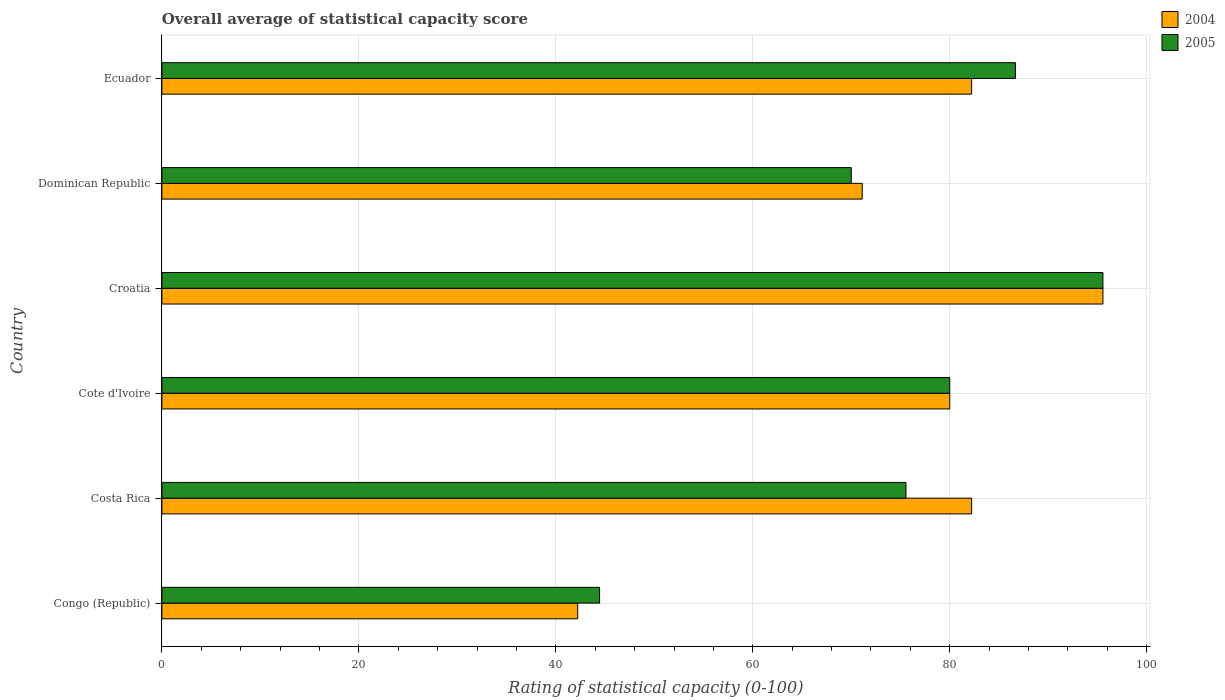How many different coloured bars are there?
Make the answer very short. 2. How many groups of bars are there?
Provide a short and direct response. 6. Are the number of bars on each tick of the Y-axis equal?
Offer a terse response. Yes. What is the label of the 3rd group of bars from the top?
Ensure brevity in your answer.  Croatia. In how many cases, is the number of bars for a given country not equal to the number of legend labels?
Give a very brief answer. 0. What is the rating of statistical capacity in 2004 in Ecuador?
Provide a succinct answer. 82.22. Across all countries, what is the maximum rating of statistical capacity in 2005?
Give a very brief answer. 95.56. Across all countries, what is the minimum rating of statistical capacity in 2005?
Offer a terse response. 44.44. In which country was the rating of statistical capacity in 2004 maximum?
Ensure brevity in your answer.  Croatia. In which country was the rating of statistical capacity in 2004 minimum?
Offer a terse response. Congo (Republic). What is the total rating of statistical capacity in 2004 in the graph?
Keep it short and to the point. 453.33. What is the difference between the rating of statistical capacity in 2004 in Congo (Republic) and that in Costa Rica?
Your answer should be very brief. -40. What is the difference between the rating of statistical capacity in 2005 in Costa Rica and the rating of statistical capacity in 2004 in Dominican Republic?
Provide a succinct answer. 4.44. What is the average rating of statistical capacity in 2004 per country?
Your response must be concise. 75.56. What is the difference between the rating of statistical capacity in 2004 and rating of statistical capacity in 2005 in Ecuador?
Your response must be concise. -4.44. What is the ratio of the rating of statistical capacity in 2004 in Croatia to that in Ecuador?
Make the answer very short. 1.16. Is the rating of statistical capacity in 2004 in Costa Rica less than that in Croatia?
Make the answer very short. Yes. What is the difference between the highest and the second highest rating of statistical capacity in 2004?
Your answer should be very brief. 13.33. What is the difference between the highest and the lowest rating of statistical capacity in 2005?
Your response must be concise. 51.11. How many bars are there?
Your answer should be compact. 12. Does the graph contain grids?
Offer a very short reply. Yes. What is the title of the graph?
Ensure brevity in your answer.  Overall average of statistical capacity score. Does "2002" appear as one of the legend labels in the graph?
Provide a short and direct response. No. What is the label or title of the X-axis?
Your answer should be very brief. Rating of statistical capacity (0-100). What is the label or title of the Y-axis?
Your answer should be very brief. Country. What is the Rating of statistical capacity (0-100) of 2004 in Congo (Republic)?
Offer a very short reply. 42.22. What is the Rating of statistical capacity (0-100) in 2005 in Congo (Republic)?
Offer a very short reply. 44.44. What is the Rating of statistical capacity (0-100) in 2004 in Costa Rica?
Keep it short and to the point. 82.22. What is the Rating of statistical capacity (0-100) in 2005 in Costa Rica?
Make the answer very short. 75.56. What is the Rating of statistical capacity (0-100) of 2004 in Cote d'Ivoire?
Your response must be concise. 80. What is the Rating of statistical capacity (0-100) in 2004 in Croatia?
Provide a short and direct response. 95.56. What is the Rating of statistical capacity (0-100) in 2005 in Croatia?
Provide a succinct answer. 95.56. What is the Rating of statistical capacity (0-100) of 2004 in Dominican Republic?
Your answer should be compact. 71.11. What is the Rating of statistical capacity (0-100) in 2004 in Ecuador?
Ensure brevity in your answer.  82.22. What is the Rating of statistical capacity (0-100) in 2005 in Ecuador?
Give a very brief answer. 86.67. Across all countries, what is the maximum Rating of statistical capacity (0-100) in 2004?
Your response must be concise. 95.56. Across all countries, what is the maximum Rating of statistical capacity (0-100) in 2005?
Provide a succinct answer. 95.56. Across all countries, what is the minimum Rating of statistical capacity (0-100) in 2004?
Provide a succinct answer. 42.22. Across all countries, what is the minimum Rating of statistical capacity (0-100) in 2005?
Offer a very short reply. 44.44. What is the total Rating of statistical capacity (0-100) in 2004 in the graph?
Offer a very short reply. 453.33. What is the total Rating of statistical capacity (0-100) of 2005 in the graph?
Your answer should be compact. 452.22. What is the difference between the Rating of statistical capacity (0-100) in 2005 in Congo (Republic) and that in Costa Rica?
Your answer should be compact. -31.11. What is the difference between the Rating of statistical capacity (0-100) in 2004 in Congo (Republic) and that in Cote d'Ivoire?
Offer a very short reply. -37.78. What is the difference between the Rating of statistical capacity (0-100) of 2005 in Congo (Republic) and that in Cote d'Ivoire?
Ensure brevity in your answer.  -35.56. What is the difference between the Rating of statistical capacity (0-100) in 2004 in Congo (Republic) and that in Croatia?
Keep it short and to the point. -53.33. What is the difference between the Rating of statistical capacity (0-100) in 2005 in Congo (Republic) and that in Croatia?
Your answer should be compact. -51.11. What is the difference between the Rating of statistical capacity (0-100) in 2004 in Congo (Republic) and that in Dominican Republic?
Provide a short and direct response. -28.89. What is the difference between the Rating of statistical capacity (0-100) of 2005 in Congo (Republic) and that in Dominican Republic?
Make the answer very short. -25.56. What is the difference between the Rating of statistical capacity (0-100) in 2005 in Congo (Republic) and that in Ecuador?
Provide a succinct answer. -42.22. What is the difference between the Rating of statistical capacity (0-100) of 2004 in Costa Rica and that in Cote d'Ivoire?
Offer a terse response. 2.22. What is the difference between the Rating of statistical capacity (0-100) in 2005 in Costa Rica and that in Cote d'Ivoire?
Your answer should be very brief. -4.44. What is the difference between the Rating of statistical capacity (0-100) in 2004 in Costa Rica and that in Croatia?
Keep it short and to the point. -13.33. What is the difference between the Rating of statistical capacity (0-100) of 2004 in Costa Rica and that in Dominican Republic?
Your answer should be compact. 11.11. What is the difference between the Rating of statistical capacity (0-100) in 2005 in Costa Rica and that in Dominican Republic?
Make the answer very short. 5.56. What is the difference between the Rating of statistical capacity (0-100) of 2004 in Costa Rica and that in Ecuador?
Your response must be concise. 0. What is the difference between the Rating of statistical capacity (0-100) in 2005 in Costa Rica and that in Ecuador?
Keep it short and to the point. -11.11. What is the difference between the Rating of statistical capacity (0-100) of 2004 in Cote d'Ivoire and that in Croatia?
Keep it short and to the point. -15.56. What is the difference between the Rating of statistical capacity (0-100) of 2005 in Cote d'Ivoire and that in Croatia?
Offer a very short reply. -15.56. What is the difference between the Rating of statistical capacity (0-100) of 2004 in Cote d'Ivoire and that in Dominican Republic?
Give a very brief answer. 8.89. What is the difference between the Rating of statistical capacity (0-100) in 2005 in Cote d'Ivoire and that in Dominican Republic?
Offer a very short reply. 10. What is the difference between the Rating of statistical capacity (0-100) in 2004 in Cote d'Ivoire and that in Ecuador?
Offer a very short reply. -2.22. What is the difference between the Rating of statistical capacity (0-100) of 2005 in Cote d'Ivoire and that in Ecuador?
Ensure brevity in your answer.  -6.67. What is the difference between the Rating of statistical capacity (0-100) of 2004 in Croatia and that in Dominican Republic?
Keep it short and to the point. 24.44. What is the difference between the Rating of statistical capacity (0-100) of 2005 in Croatia and that in Dominican Republic?
Offer a terse response. 25.56. What is the difference between the Rating of statistical capacity (0-100) in 2004 in Croatia and that in Ecuador?
Give a very brief answer. 13.33. What is the difference between the Rating of statistical capacity (0-100) of 2005 in Croatia and that in Ecuador?
Offer a very short reply. 8.89. What is the difference between the Rating of statistical capacity (0-100) in 2004 in Dominican Republic and that in Ecuador?
Your answer should be very brief. -11.11. What is the difference between the Rating of statistical capacity (0-100) of 2005 in Dominican Republic and that in Ecuador?
Keep it short and to the point. -16.67. What is the difference between the Rating of statistical capacity (0-100) of 2004 in Congo (Republic) and the Rating of statistical capacity (0-100) of 2005 in Costa Rica?
Offer a terse response. -33.33. What is the difference between the Rating of statistical capacity (0-100) in 2004 in Congo (Republic) and the Rating of statistical capacity (0-100) in 2005 in Cote d'Ivoire?
Offer a terse response. -37.78. What is the difference between the Rating of statistical capacity (0-100) in 2004 in Congo (Republic) and the Rating of statistical capacity (0-100) in 2005 in Croatia?
Give a very brief answer. -53.33. What is the difference between the Rating of statistical capacity (0-100) in 2004 in Congo (Republic) and the Rating of statistical capacity (0-100) in 2005 in Dominican Republic?
Your answer should be compact. -27.78. What is the difference between the Rating of statistical capacity (0-100) in 2004 in Congo (Republic) and the Rating of statistical capacity (0-100) in 2005 in Ecuador?
Ensure brevity in your answer.  -44.44. What is the difference between the Rating of statistical capacity (0-100) in 2004 in Costa Rica and the Rating of statistical capacity (0-100) in 2005 in Cote d'Ivoire?
Your answer should be very brief. 2.22. What is the difference between the Rating of statistical capacity (0-100) in 2004 in Costa Rica and the Rating of statistical capacity (0-100) in 2005 in Croatia?
Give a very brief answer. -13.33. What is the difference between the Rating of statistical capacity (0-100) of 2004 in Costa Rica and the Rating of statistical capacity (0-100) of 2005 in Dominican Republic?
Give a very brief answer. 12.22. What is the difference between the Rating of statistical capacity (0-100) in 2004 in Costa Rica and the Rating of statistical capacity (0-100) in 2005 in Ecuador?
Offer a terse response. -4.44. What is the difference between the Rating of statistical capacity (0-100) of 2004 in Cote d'Ivoire and the Rating of statistical capacity (0-100) of 2005 in Croatia?
Your response must be concise. -15.56. What is the difference between the Rating of statistical capacity (0-100) of 2004 in Cote d'Ivoire and the Rating of statistical capacity (0-100) of 2005 in Ecuador?
Provide a succinct answer. -6.67. What is the difference between the Rating of statistical capacity (0-100) of 2004 in Croatia and the Rating of statistical capacity (0-100) of 2005 in Dominican Republic?
Offer a terse response. 25.56. What is the difference between the Rating of statistical capacity (0-100) of 2004 in Croatia and the Rating of statistical capacity (0-100) of 2005 in Ecuador?
Ensure brevity in your answer.  8.89. What is the difference between the Rating of statistical capacity (0-100) of 2004 in Dominican Republic and the Rating of statistical capacity (0-100) of 2005 in Ecuador?
Offer a very short reply. -15.56. What is the average Rating of statistical capacity (0-100) in 2004 per country?
Give a very brief answer. 75.56. What is the average Rating of statistical capacity (0-100) in 2005 per country?
Your response must be concise. 75.37. What is the difference between the Rating of statistical capacity (0-100) in 2004 and Rating of statistical capacity (0-100) in 2005 in Congo (Republic)?
Offer a terse response. -2.22. What is the difference between the Rating of statistical capacity (0-100) of 2004 and Rating of statistical capacity (0-100) of 2005 in Cote d'Ivoire?
Your response must be concise. 0. What is the difference between the Rating of statistical capacity (0-100) in 2004 and Rating of statistical capacity (0-100) in 2005 in Dominican Republic?
Provide a succinct answer. 1.11. What is the difference between the Rating of statistical capacity (0-100) in 2004 and Rating of statistical capacity (0-100) in 2005 in Ecuador?
Your response must be concise. -4.44. What is the ratio of the Rating of statistical capacity (0-100) of 2004 in Congo (Republic) to that in Costa Rica?
Your answer should be very brief. 0.51. What is the ratio of the Rating of statistical capacity (0-100) in 2005 in Congo (Republic) to that in Costa Rica?
Make the answer very short. 0.59. What is the ratio of the Rating of statistical capacity (0-100) in 2004 in Congo (Republic) to that in Cote d'Ivoire?
Your answer should be compact. 0.53. What is the ratio of the Rating of statistical capacity (0-100) of 2005 in Congo (Republic) to that in Cote d'Ivoire?
Give a very brief answer. 0.56. What is the ratio of the Rating of statistical capacity (0-100) in 2004 in Congo (Republic) to that in Croatia?
Keep it short and to the point. 0.44. What is the ratio of the Rating of statistical capacity (0-100) of 2005 in Congo (Republic) to that in Croatia?
Your answer should be very brief. 0.47. What is the ratio of the Rating of statistical capacity (0-100) of 2004 in Congo (Republic) to that in Dominican Republic?
Offer a terse response. 0.59. What is the ratio of the Rating of statistical capacity (0-100) of 2005 in Congo (Republic) to that in Dominican Republic?
Provide a short and direct response. 0.63. What is the ratio of the Rating of statistical capacity (0-100) of 2004 in Congo (Republic) to that in Ecuador?
Your answer should be very brief. 0.51. What is the ratio of the Rating of statistical capacity (0-100) of 2005 in Congo (Republic) to that in Ecuador?
Your answer should be compact. 0.51. What is the ratio of the Rating of statistical capacity (0-100) of 2004 in Costa Rica to that in Cote d'Ivoire?
Give a very brief answer. 1.03. What is the ratio of the Rating of statistical capacity (0-100) in 2005 in Costa Rica to that in Cote d'Ivoire?
Your answer should be very brief. 0.94. What is the ratio of the Rating of statistical capacity (0-100) in 2004 in Costa Rica to that in Croatia?
Your response must be concise. 0.86. What is the ratio of the Rating of statistical capacity (0-100) of 2005 in Costa Rica to that in Croatia?
Give a very brief answer. 0.79. What is the ratio of the Rating of statistical capacity (0-100) in 2004 in Costa Rica to that in Dominican Republic?
Offer a very short reply. 1.16. What is the ratio of the Rating of statistical capacity (0-100) of 2005 in Costa Rica to that in Dominican Republic?
Give a very brief answer. 1.08. What is the ratio of the Rating of statistical capacity (0-100) in 2004 in Costa Rica to that in Ecuador?
Give a very brief answer. 1. What is the ratio of the Rating of statistical capacity (0-100) in 2005 in Costa Rica to that in Ecuador?
Give a very brief answer. 0.87. What is the ratio of the Rating of statistical capacity (0-100) of 2004 in Cote d'Ivoire to that in Croatia?
Your answer should be very brief. 0.84. What is the ratio of the Rating of statistical capacity (0-100) in 2005 in Cote d'Ivoire to that in Croatia?
Give a very brief answer. 0.84. What is the ratio of the Rating of statistical capacity (0-100) in 2005 in Cote d'Ivoire to that in Dominican Republic?
Make the answer very short. 1.14. What is the ratio of the Rating of statistical capacity (0-100) in 2004 in Croatia to that in Dominican Republic?
Your response must be concise. 1.34. What is the ratio of the Rating of statistical capacity (0-100) in 2005 in Croatia to that in Dominican Republic?
Offer a terse response. 1.37. What is the ratio of the Rating of statistical capacity (0-100) in 2004 in Croatia to that in Ecuador?
Your answer should be very brief. 1.16. What is the ratio of the Rating of statistical capacity (0-100) in 2005 in Croatia to that in Ecuador?
Give a very brief answer. 1.1. What is the ratio of the Rating of statistical capacity (0-100) in 2004 in Dominican Republic to that in Ecuador?
Offer a very short reply. 0.86. What is the ratio of the Rating of statistical capacity (0-100) in 2005 in Dominican Republic to that in Ecuador?
Give a very brief answer. 0.81. What is the difference between the highest and the second highest Rating of statistical capacity (0-100) of 2004?
Provide a short and direct response. 13.33. What is the difference between the highest and the second highest Rating of statistical capacity (0-100) of 2005?
Your answer should be very brief. 8.89. What is the difference between the highest and the lowest Rating of statistical capacity (0-100) in 2004?
Provide a succinct answer. 53.33. What is the difference between the highest and the lowest Rating of statistical capacity (0-100) of 2005?
Make the answer very short. 51.11. 